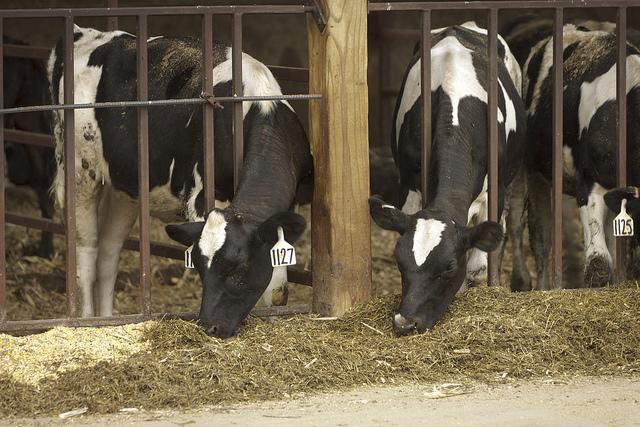Describe how these cows might feel during different seasons of the year. During the spring, the cows might feel refreshed and energized as new grass begins to grow, and the temperatures are milder. Summer might bring a sense of laziness and contentment, as the warm weather makes them bask in the sun if they have an outdoor area. In the fall, the cooling temperatures might make them feel lively yet comfortable preparing for the colder weather. Winter could be a mix of discomfort from the cold, but also a sense of coziness if they are kept warm inside the barn. Each season brings a unique set of sensory experiences that affect their moods and behaviors. 